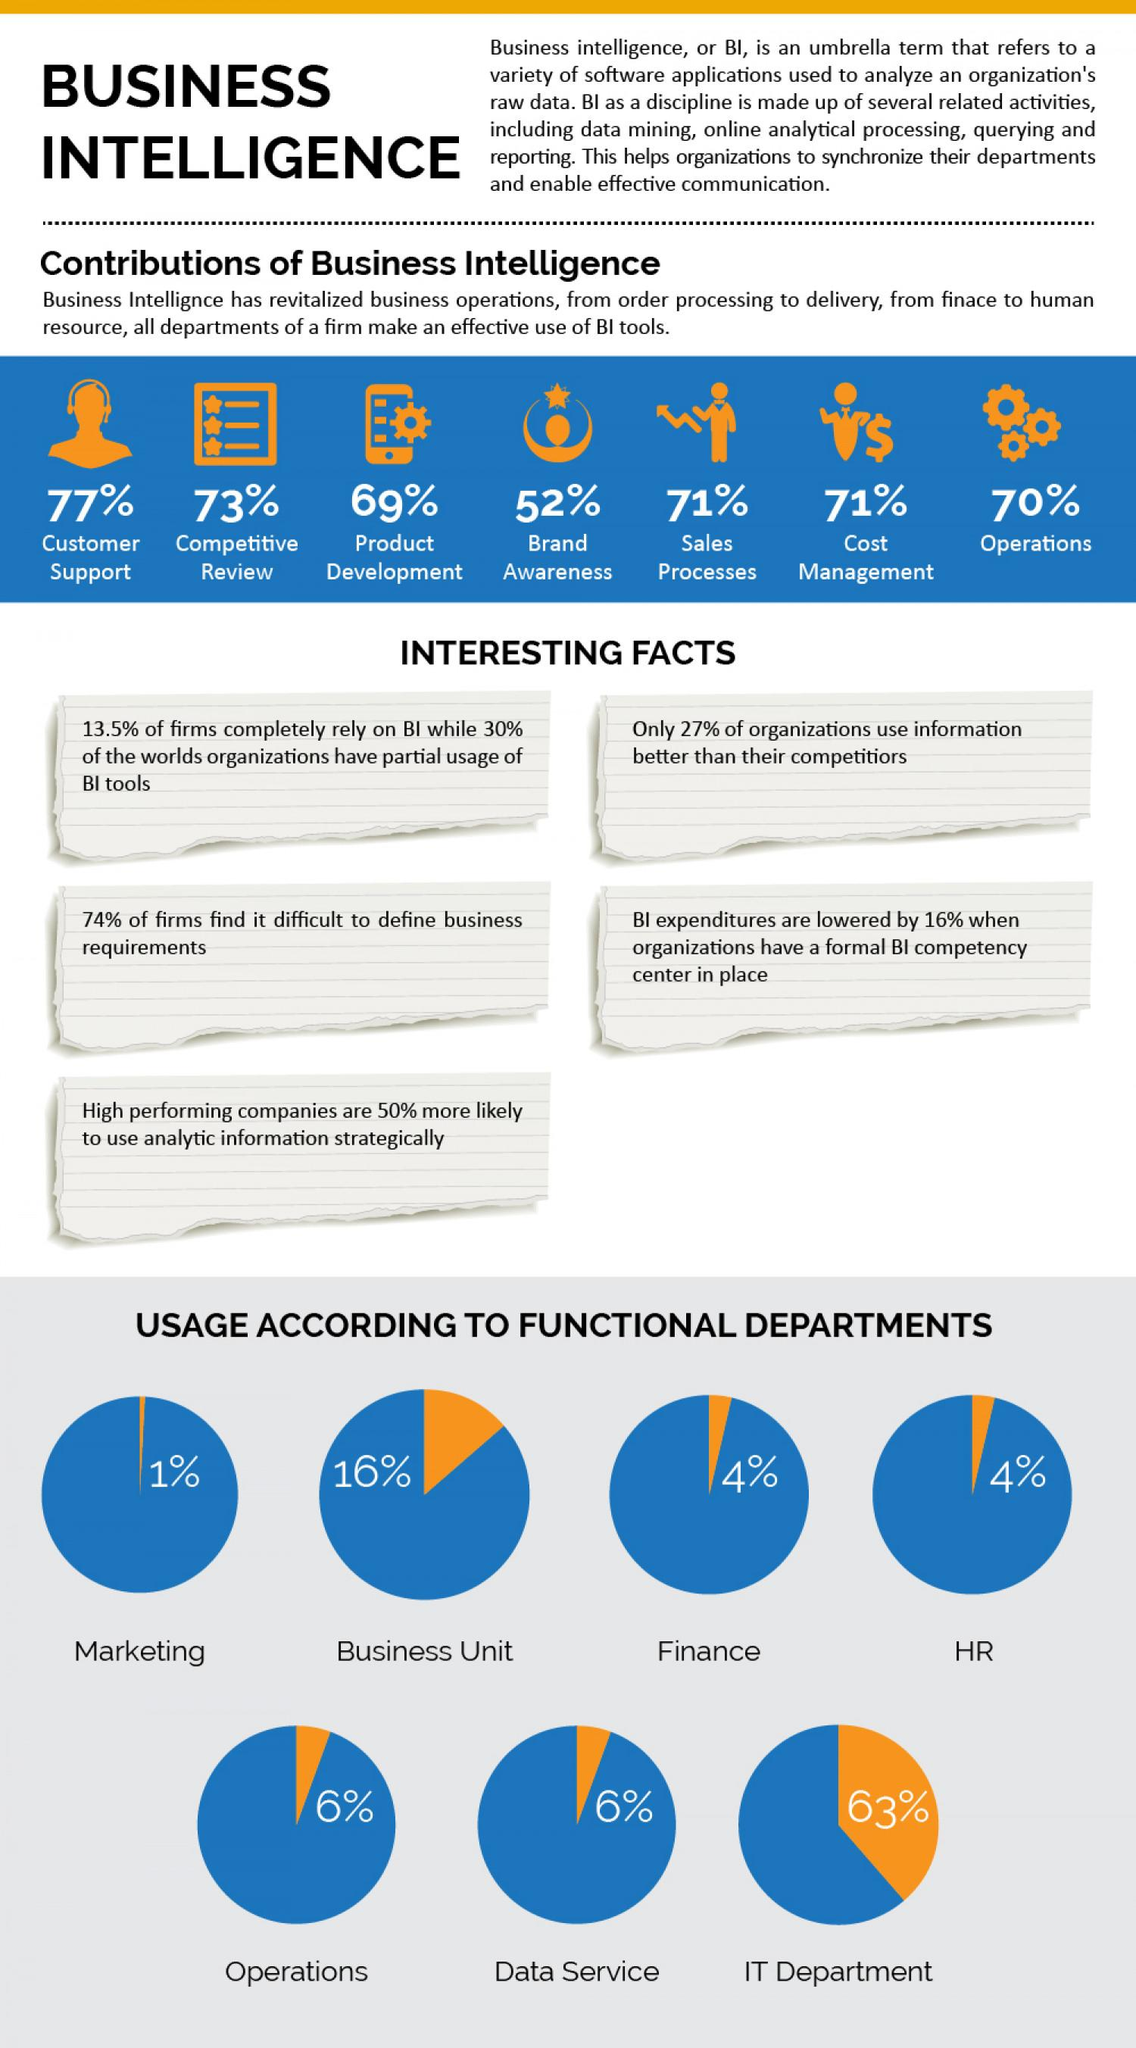Specify some key components in this picture. A formal BI competency center in place within an organization results in a 16% reduction in BI expenditure. The contribution of Business Intelligence (BI) to sales processes has been consistent with cost management. The contribution of Business Intelligence in product development has been the second lowest among all areas. The Human Resources department has the same level of usage of Business Intelligence as the Finance department. According to our data, only 6% of the functional departments are currently using Business Intelligence (BI). This includes departments such as Operations and Data Services. 